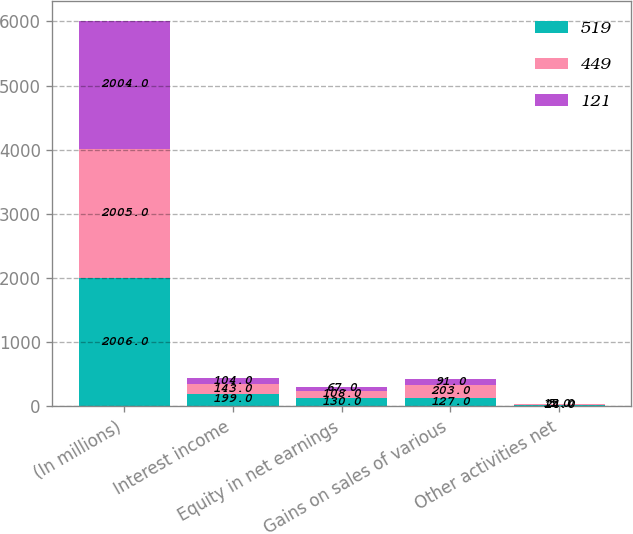Convert chart to OTSL. <chart><loc_0><loc_0><loc_500><loc_500><stacked_bar_chart><ecel><fcel>(In millions)<fcel>Interest income<fcel>Equity in net earnings<fcel>Gains on sales of various<fcel>Other activities net<nl><fcel>519<fcel>2006<fcel>199<fcel>130<fcel>127<fcel>24<nl><fcel>449<fcel>2005<fcel>143<fcel>108<fcel>203<fcel>5<nl><fcel>121<fcel>2004<fcel>104<fcel>67<fcel>91<fcel>15<nl></chart> 